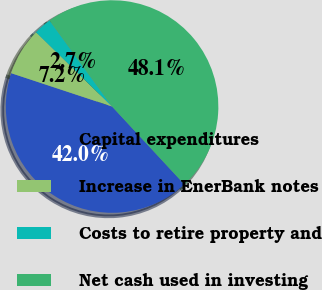Convert chart to OTSL. <chart><loc_0><loc_0><loc_500><loc_500><pie_chart><fcel>Capital expenditures<fcel>Increase in EnerBank notes<fcel>Costs to retire property and<fcel>Net cash used in investing<nl><fcel>41.99%<fcel>7.23%<fcel>2.69%<fcel>48.09%<nl></chart> 